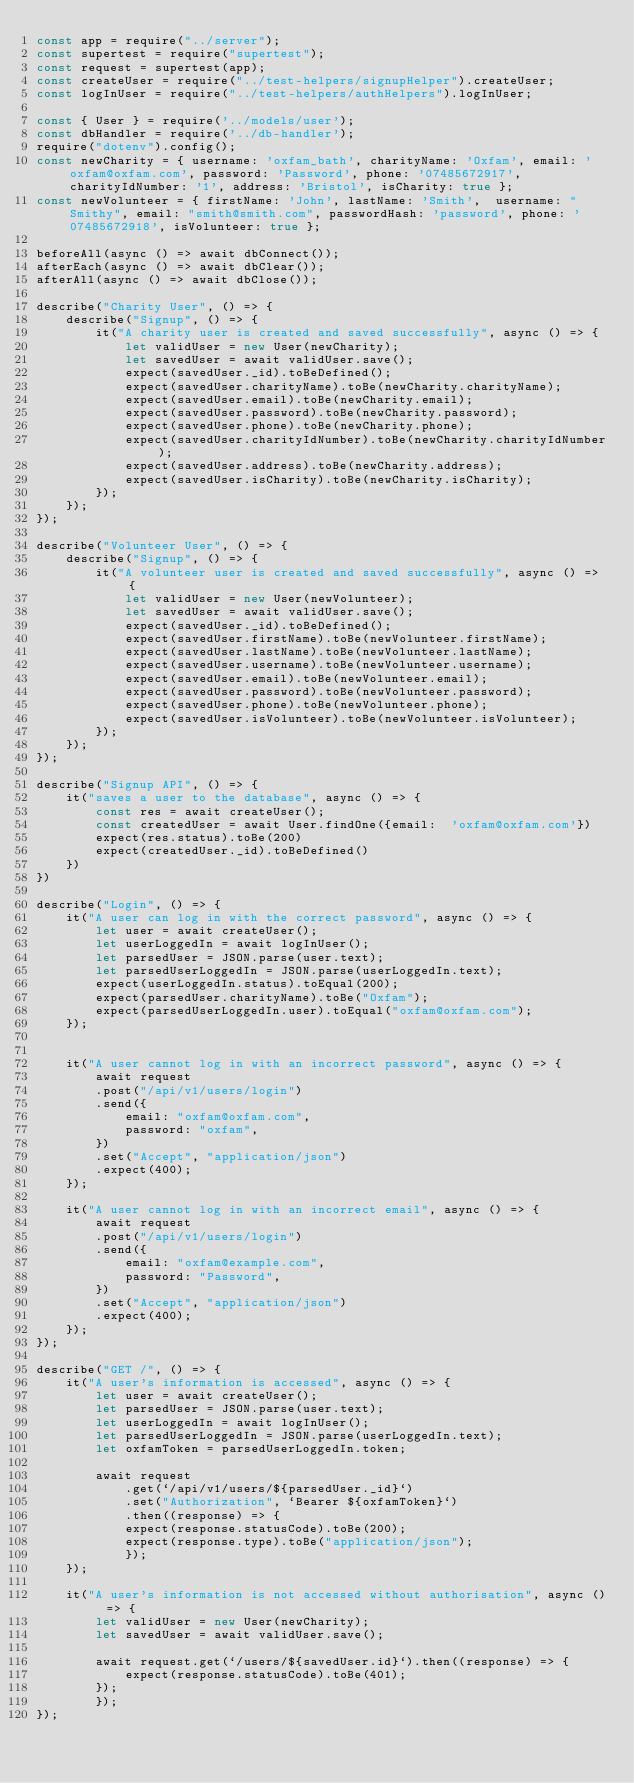Convert code to text. <code><loc_0><loc_0><loc_500><loc_500><_JavaScript_>const app = require("../server");
const supertest = require("supertest");
const request = supertest(app);
const createUser = require("../test-helpers/signupHelper").createUser;
const logInUser = require("../test-helpers/authHelpers").logInUser;

const { User } = require('../models/user');
const dbHandler = require('../db-handler');
require("dotenv").config();
const newCharity = { username: 'oxfam_bath', charityName: 'Oxfam', email: 'oxfam@oxfam.com', password: 'Password', phone: '07485672917', charityIdNumber: '1', address: 'Bristol', isCharity: true };
const newVolunteer = { firstName: 'John', lastName: 'Smith',  username: "Smithy", email: "smith@smith.com", passwordHash: 'password', phone: '07485672918', isVolunteer: true };

beforeAll(async () => await dbConnect());
afterEach(async () => await dbClear());
afterAll(async () => await dbClose());

describe("Charity User", () => {
    describe("Signup", () => {
        it("A charity user is created and saved successfully", async () => {
            let validUser = new User(newCharity);
            let savedUser = await validUser.save();
            expect(savedUser._id).toBeDefined();
            expect(savedUser.charityName).toBe(newCharity.charityName);
            expect(savedUser.email).toBe(newCharity.email);
            expect(savedUser.password).toBe(newCharity.password);
            expect(savedUser.phone).toBe(newCharity.phone);
            expect(savedUser.charityIdNumber).toBe(newCharity.charityIdNumber);
            expect(savedUser.address).toBe(newCharity.address);
            expect(savedUser.isCharity).toBe(newCharity.isCharity);
        });
    });
});

describe("Volunteer User", () => {
    describe("Signup", () => {
        it("A volunteer user is created and saved successfully", async () => {
            let validUser = new User(newVolunteer);
            let savedUser = await validUser.save();
            expect(savedUser._id).toBeDefined();
            expect(savedUser.firstName).toBe(newVolunteer.firstName);
            expect(savedUser.lastName).toBe(newVolunteer.lastName);
            expect(savedUser.username).toBe(newVolunteer.username);
            expect(savedUser.email).toBe(newVolunteer.email);
            expect(savedUser.password).toBe(newVolunteer.password);
            expect(savedUser.phone).toBe(newVolunteer.phone);
            expect(savedUser.isVolunteer).toBe(newVolunteer.isVolunteer);
        });
    });
});

describe("Signup API", () => {
    it("saves a user to the database", async () => {
        const res = await createUser();
        const createdUser = await User.findOne({email:  'oxfam@oxfam.com'})
        expect(res.status).toBe(200)
        expect(createdUser._id).toBeDefined()
    })
})

describe("Login", () => {
    it("A user can log in with the correct password", async () => {
        let user = await createUser();
        let userLoggedIn = await logInUser();
        let parsedUser = JSON.parse(user.text);
        let parsedUserLoggedIn = JSON.parse(userLoggedIn.text);
        expect(userLoggedIn.status).toEqual(200);
        expect(parsedUser.charityName).toBe("Oxfam");
        expect(parsedUserLoggedIn.user).toEqual("oxfam@oxfam.com");
    });


    it("A user cannot log in with an incorrect password", async () => {
        await request
        .post("/api/v1/users/login")
        .send({
            email: "oxfam@oxfam.com",
            password: "oxfam",
        })
        .set("Accept", "application/json")
        .expect(400);
    });

    it("A user cannot log in with an incorrect email", async () => {
        await request
        .post("/api/v1/users/login")
        .send({
            email: "oxfam@example.com",
            password: "Password",
        })
        .set("Accept", "application/json")
        .expect(400);
    });
});

describe("GET /", () => {
    it("A user's information is accessed", async () => {
        let user = await createUser();
        let parsedUser = JSON.parse(user.text);
        let userLoggedIn = await logInUser();
        let parsedUserLoggedIn = JSON.parse(userLoggedIn.text);
        let oxfamToken = parsedUserLoggedIn.token;

        await request
            .get(`/api/v1/users/${parsedUser._id}`)
            .set("Authorization", `Bearer ${oxfamToken}`)
            .then((response) => {
            expect(response.statusCode).toBe(200);
            expect(response.type).toBe("application/json");
            });
    });

    it("A user's information is not accessed without authorisation", async () => {
        let validUser = new User(newCharity);
        let savedUser = await validUser.save();

        await request.get(`/users/${savedUser.id}`).then((response) => {
            expect(response.statusCode).toBe(401);
        });
        });
});
</code> 